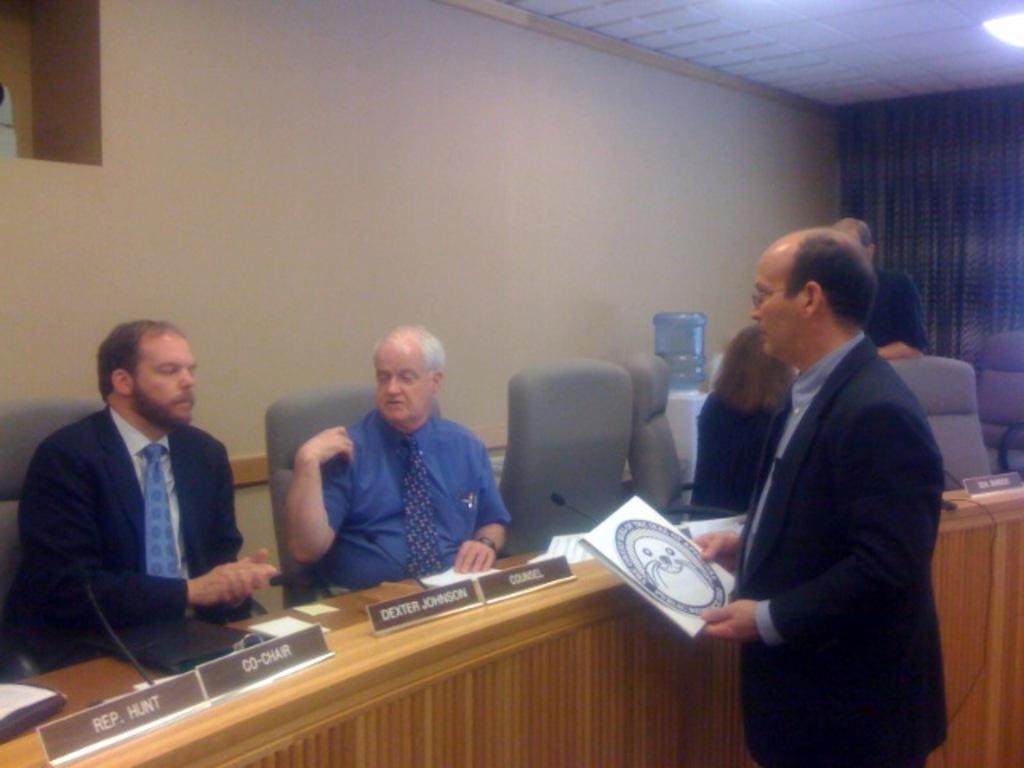Could you give a brief overview of what you see in this image? In this image in the front there is a person standing and holding a book in his hand. In the center there are persons sitting and there are empty chairs and on the table there are boards with some text written on it and there are mics. In the background there is a wall and in front of the wall there is a water cooler and there is a curtain and on the top there is a light. 